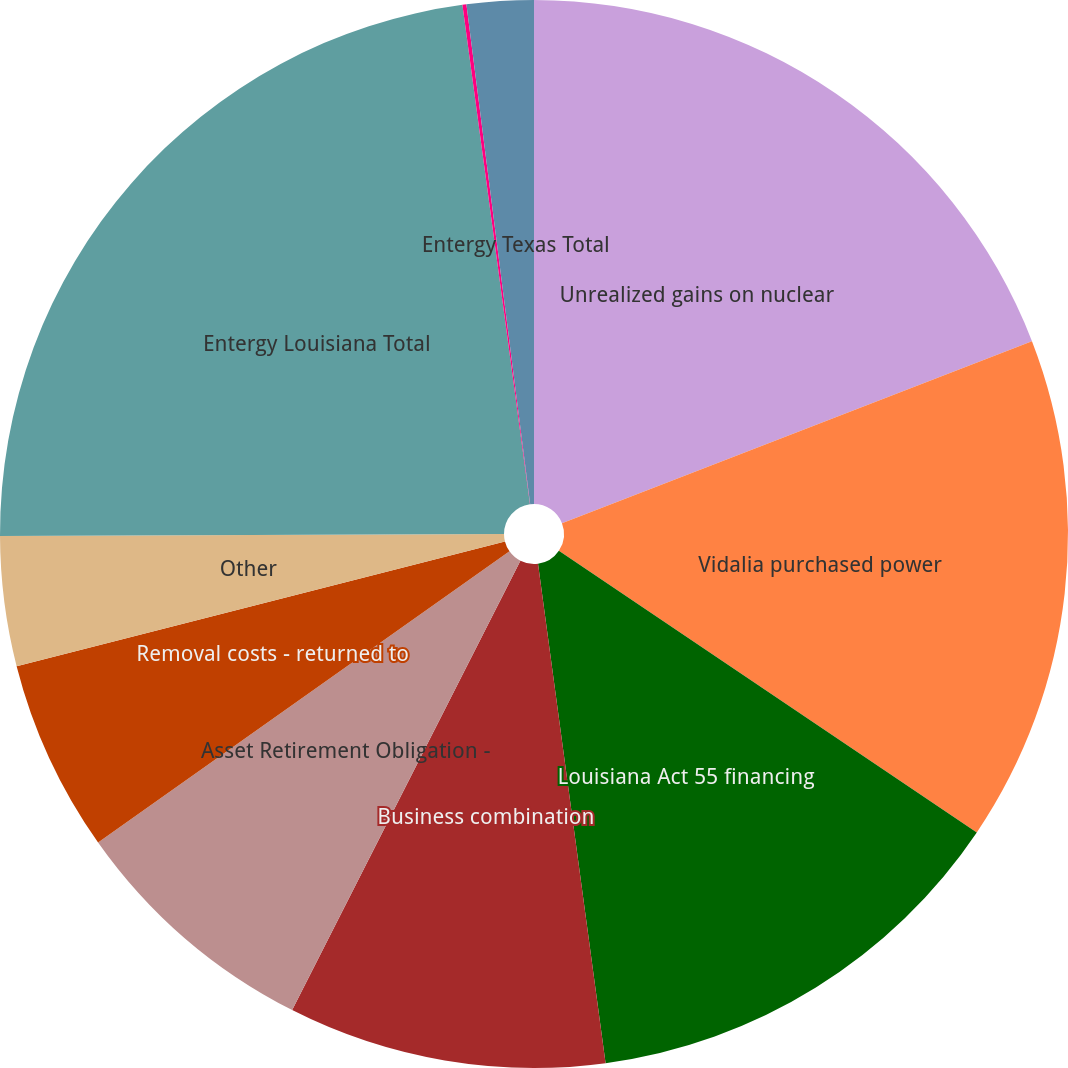<chart> <loc_0><loc_0><loc_500><loc_500><pie_chart><fcel>Unrealized gains on nuclear<fcel>Vidalia purchased power<fcel>Louisiana Act 55 financing<fcel>Business combination<fcel>Asset Retirement Obligation -<fcel>Removal costs - returned to<fcel>Other<fcel>Entergy Louisiana Total<fcel>Transition to competition<fcel>Entergy Texas Total<nl><fcel>19.12%<fcel>15.32%<fcel>13.42%<fcel>9.62%<fcel>7.72%<fcel>5.82%<fcel>3.92%<fcel>22.92%<fcel>0.12%<fcel>2.02%<nl></chart> 